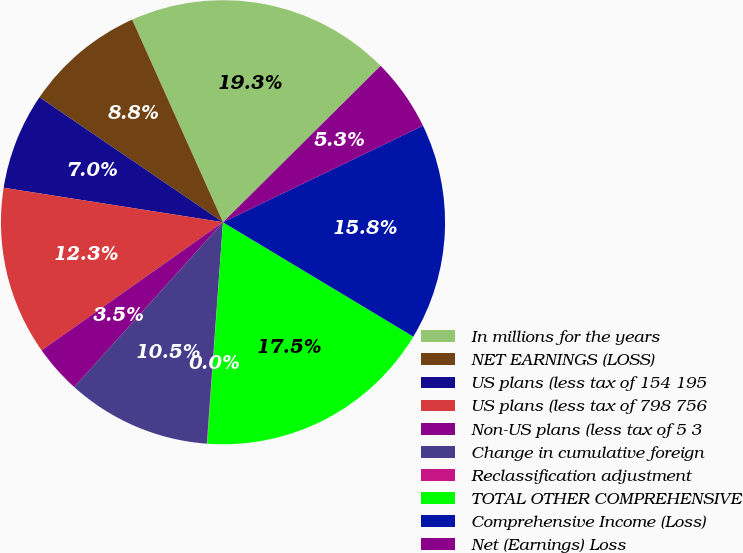Convert chart. <chart><loc_0><loc_0><loc_500><loc_500><pie_chart><fcel>In millions for the years<fcel>NET EARNINGS (LOSS)<fcel>US plans (less tax of 154 195<fcel>US plans (less tax of 798 756<fcel>Non-US plans (less tax of 5 3<fcel>Change in cumulative foreign<fcel>Reclassification adjustment<fcel>TOTAL OTHER COMPREHENSIVE<fcel>Comprehensive Income (Loss)<fcel>Net (Earnings) Loss<nl><fcel>19.27%<fcel>8.78%<fcel>7.03%<fcel>12.27%<fcel>3.53%<fcel>10.52%<fcel>0.03%<fcel>17.52%<fcel>15.77%<fcel>5.28%<nl></chart> 